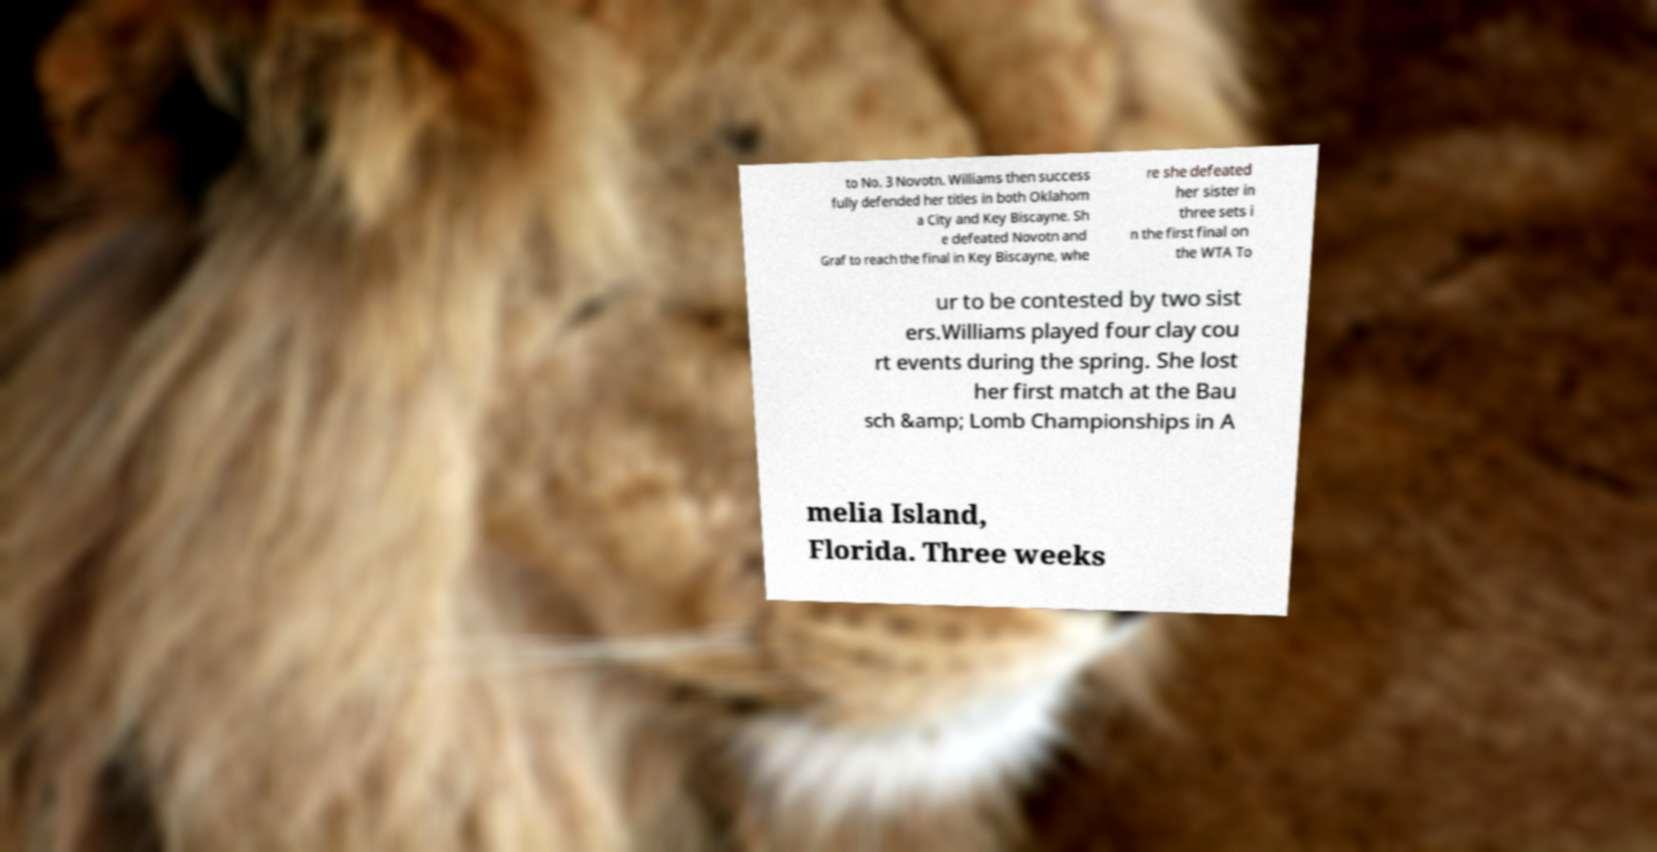What messages or text are displayed in this image? I need them in a readable, typed format. to No. 3 Novotn. Williams then success fully defended her titles in both Oklahom a City and Key Biscayne. Sh e defeated Novotn and Graf to reach the final in Key Biscayne, whe re she defeated her sister in three sets i n the first final on the WTA To ur to be contested by two sist ers.Williams played four clay cou rt events during the spring. She lost her first match at the Bau sch &amp; Lomb Championships in A melia Island, Florida. Three weeks 